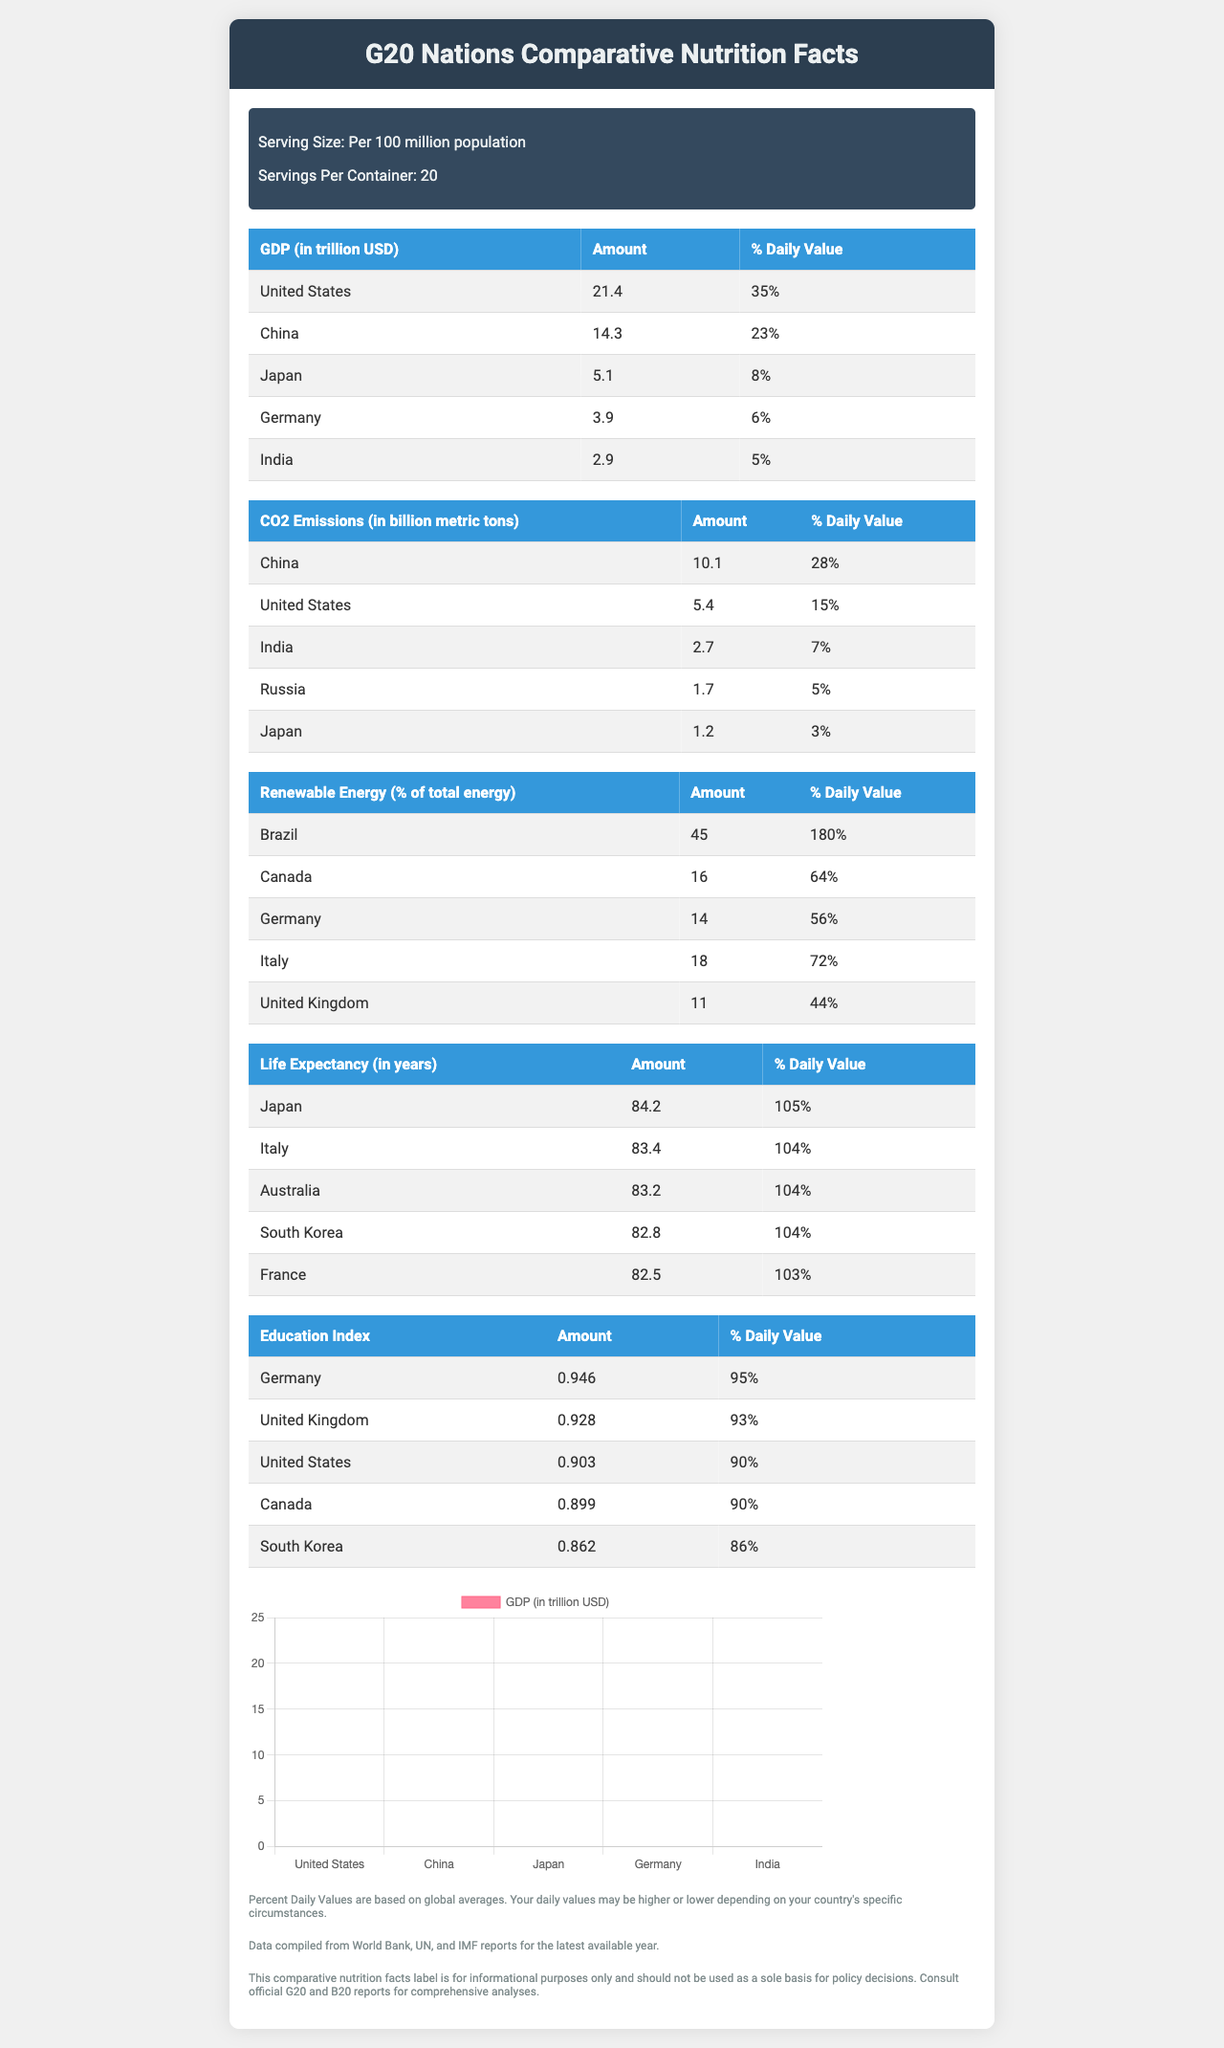what is the title of the document? The title of the document is given in the header as "G20 Nations Comparative Nutrition Facts".
Answer: G20 Nations Comparative Nutrition Facts what is the serving size mentioned in the document? The serving size is mentioned just below the header in the document.
Answer: Per 100 million population which country has the highest GDP according to the document? In the table under GDP (in trillion USD), the amount listed for the United States is 21.4, which is the highest.
Answer: United States how many countries are listed for the Education Index? The table under Education Index lists five countries: Germany, United Kingdom, United States, Canada, and South Korea.
Answer: Five what is the daily value percent of CO2 emissions for Japan? According to the CO2 Emissions table, the daily value percent for Japan is listed as 3%.
Answer: 3% which country has the highest percentage of renewable energy?  
  1. Canada  
  2. Germany  
  3. Brazil  
  4. Italy The table under Renewable Energy (% of total energy) shows Brazil with 45%, which is the highest.
Answer: 3 which of the following countries has the lowest life expectancy?  
  A. South Korea  
  B. Japan  
  C. France  
  D. Australia The table under Life Expectancy (in years) shows France with the lowest at 82.5 years.
Answer: C is China's GDP higher than Japan's GDP? The GDP for China is 14.3 trillion USD, which is significantly higher than Japan's GDP of 5.1 trillion USD.
Answer: Yes summarize the main idea of the document. The document uses a "nutrition facts" style to present and compare important statistics about the G20 nations, making it easier to see differences and similarities in key areas like economy, environment, energy, health, and education.
Answer: The document provides a comparative overview of several key metrics (like GDP, CO2 emissions, renewable energy usage, life expectancy, and education index) amongst the major G20 nations, formatted similarly to a nutrition facts label. It highlights the diverse economic, environmental, and social parameters of these countries. what is the GDP of Russia? Russia is not included in the GDP section of the document, so we cannot determine its GDP based on the provided information.
Answer: Not enough information 